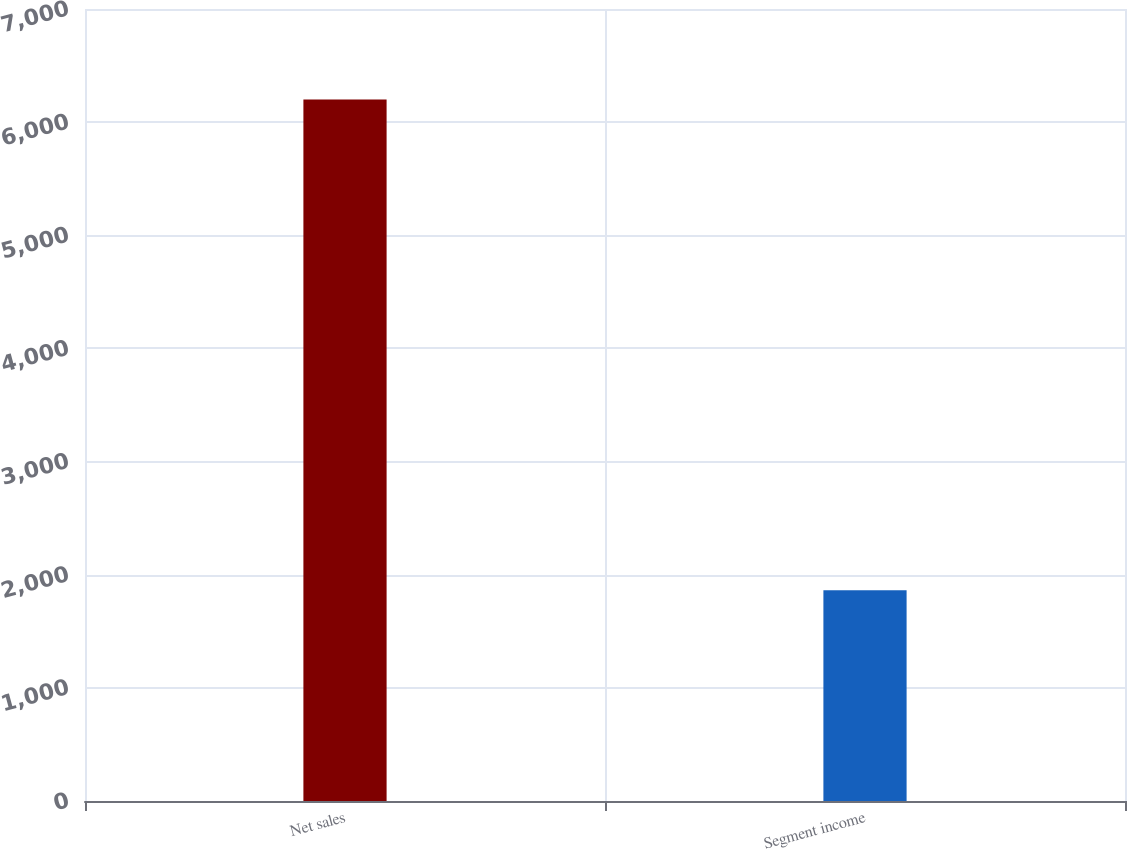Convert chart to OTSL. <chart><loc_0><loc_0><loc_500><loc_500><bar_chart><fcel>Net sales<fcel>Segment income<nl><fcel>6200.1<fcel>1862.6<nl></chart> 